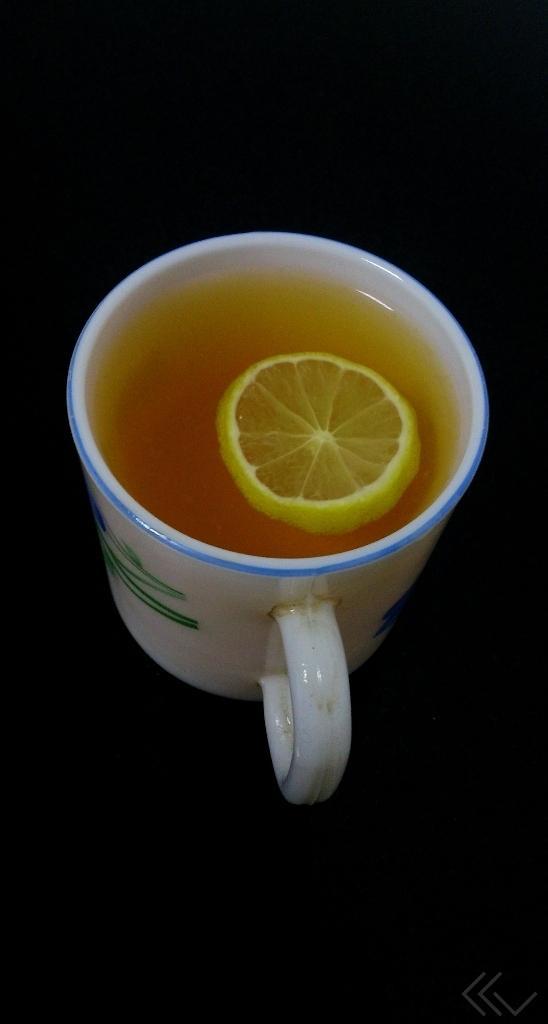How would you summarize this image in a sentence or two? In this picture there is a cup which is kept on the table. In that cup we can see black tea and lemon. 